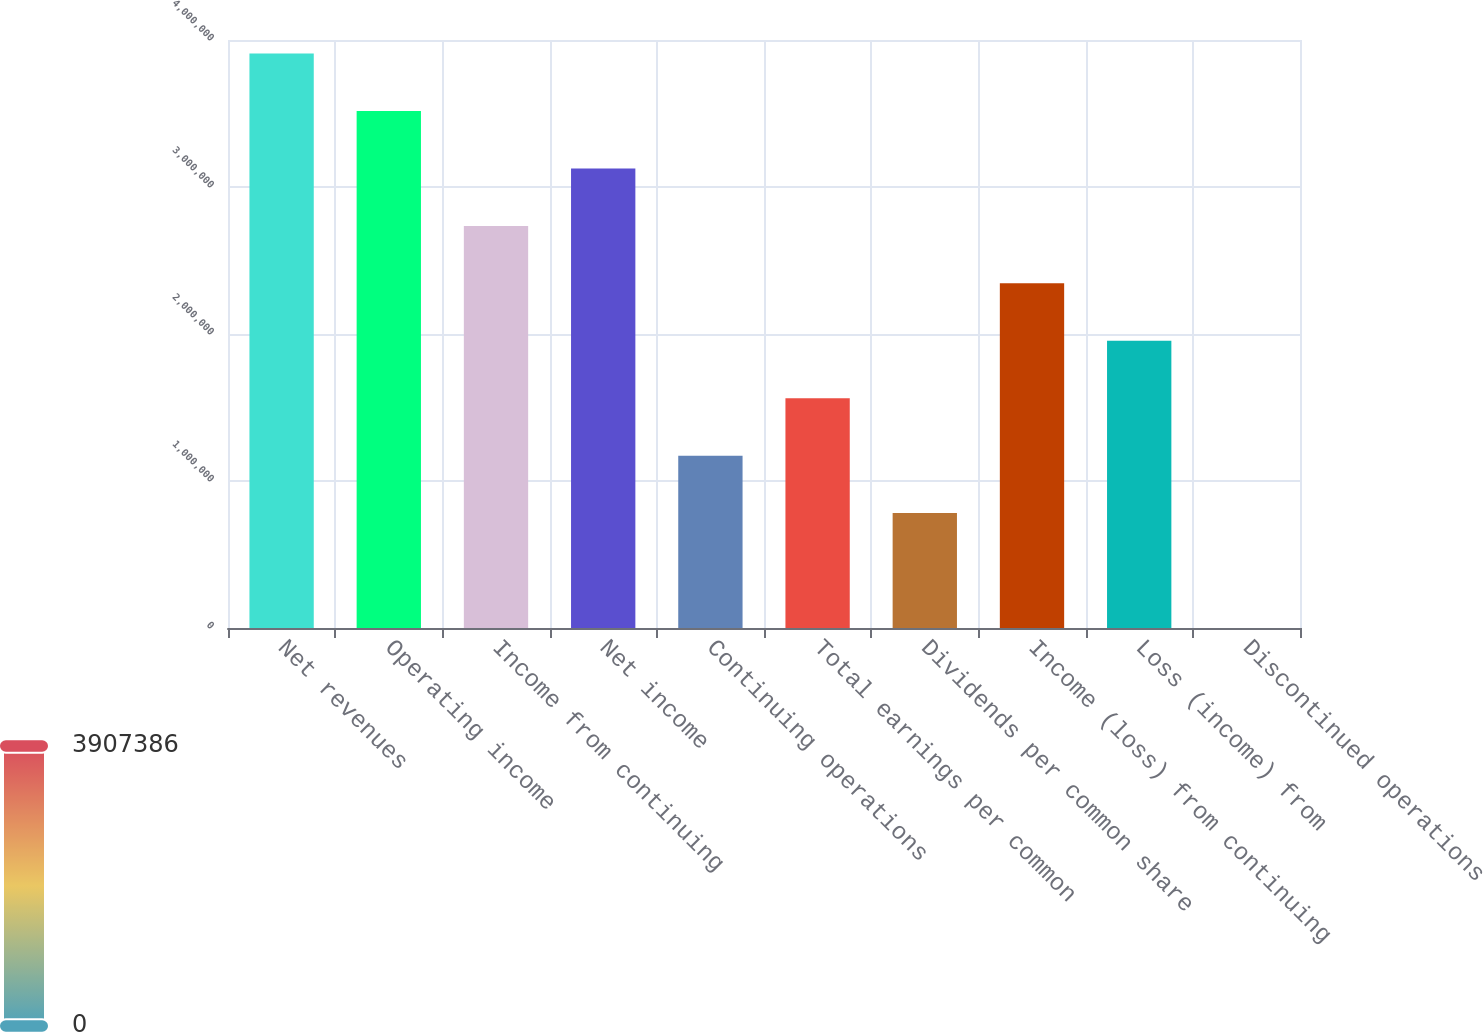Convert chart. <chart><loc_0><loc_0><loc_500><loc_500><bar_chart><fcel>Net revenues<fcel>Operating income<fcel>Income from continuing<fcel>Net income<fcel>Continuing operations<fcel>Total earnings per common<fcel>Dividends per common share<fcel>Income (loss) from continuing<fcel>Loss (income) from<fcel>Discontinued operations<nl><fcel>3.90739e+06<fcel>3.51665e+06<fcel>2.73517e+06<fcel>3.12591e+06<fcel>1.17222e+06<fcel>1.56295e+06<fcel>781477<fcel>2.34443e+06<fcel>1.95369e+06<fcel>0.01<nl></chart> 